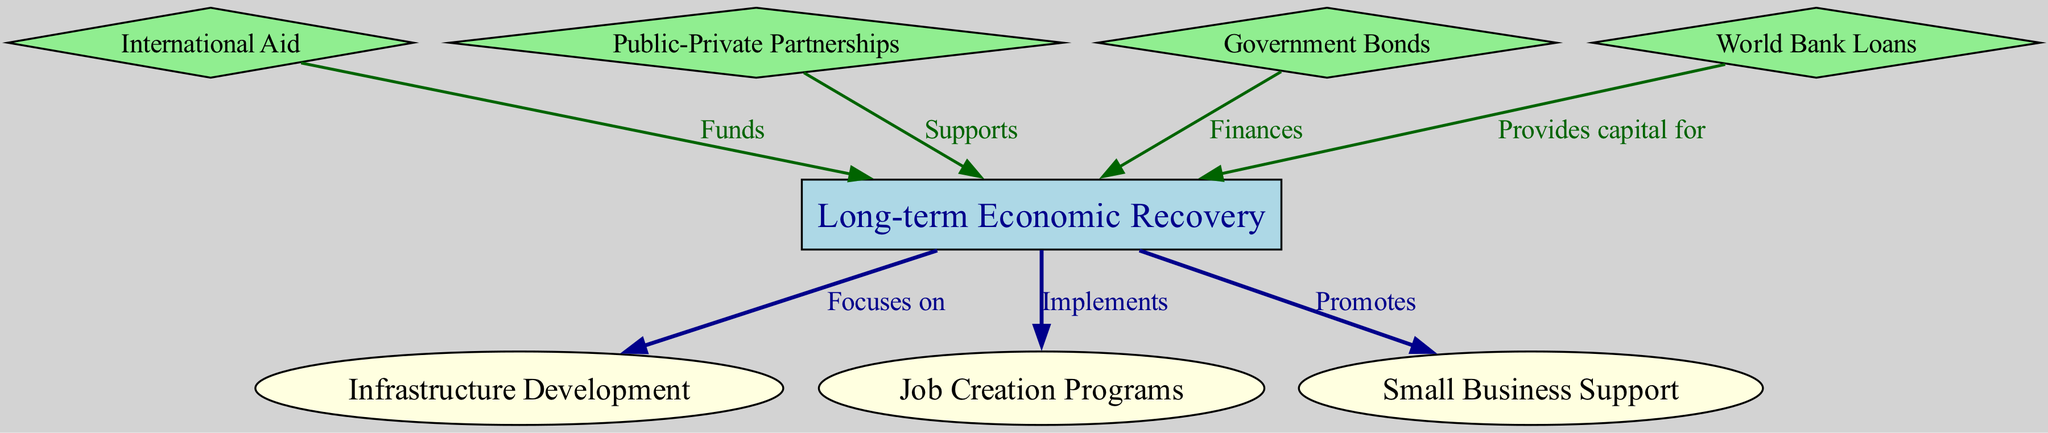What is the central concept in this diagram? The central concept is indicated by the highlighted rectangle node, which represents "Long-term Economic Recovery." All other elements in the diagram relate to this central theme.
Answer: Long-term Economic Recovery How many nodes are there in total? By counting the individual nodes listed in the data, we find there are eight distinct nodes represented in the diagram.
Answer: 8 What does "International Aid" do in relation to long-term economic recovery? The edge connecting "International Aid" to "Long-term Economic Recovery" is labelled "Funds", indicating that it provides financial resources to support the recovery efforts.
Answer: Funds Which element is related to "Job Creation Programs"? The diagram shows a direct edge from "Long-term Economic Recovery" to "Job Creation Programs," labelled "Implements," detailing that the economic recovery initiative actively works on job creation.
Answer: Implements What type of relationship exists between "Small Business Support" and "Long-term Economic Recovery"? The diagram shows a promotional relationship, with an edge labelled "Promotes" indicating that Small Business Support is encouraged as part of the long-term economic recovery strategy.
Answer: Promotes How does "Public-Private Partnerships" contribute to the economic recovery? The diagram indicates that Public-Private Partnerships "Supports" the Long-term Economic Recovery, meaning they play a role in providing resources or collaboration to help sustain recovery efforts.
Answer: Supports What financial mechanism is indicated by Government Bonds in the context of long-term economic recovery? The diagram shows that Government Bonds "Finances" the Long-term Economic Recovery, suggesting that it raises funds used for various recovery initiatives.
Answer: Finances Identify one funding source that provides capital for long-term economic recovery. In the diagram, "World Bank Loans" is connected with an edge labelled "Provides capital for," marking it as a funding source specifically designated to aid economic recovery efforts.
Answer: Provides capital for 